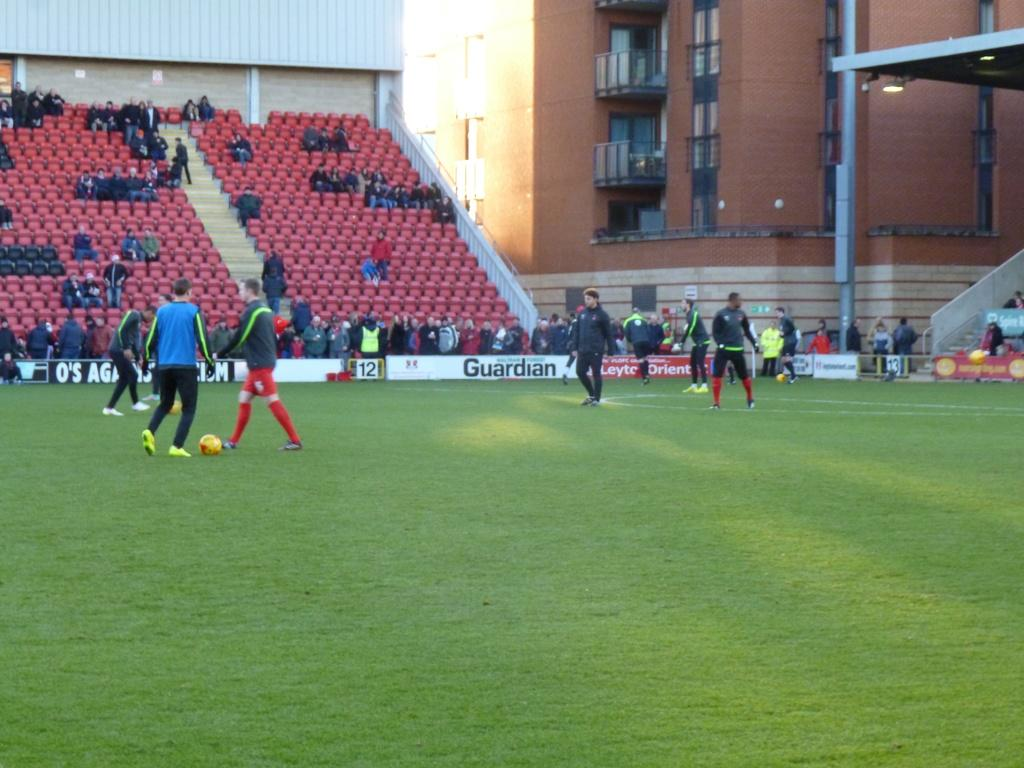<image>
Describe the image concisely. One of the signs around a soccer stadium is for the Guardian. 